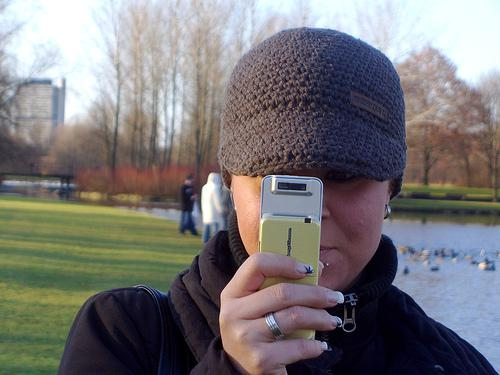Question: what color is the lady's ring?
Choices:
A. Gold.
B. Silver.
C. Yellow.
D. Grey.
Answer with the letter. Answer: B Question: where are the ducks?
Choices:
A. On the grass.
B. In the water.
C. In the sand.
D. On the carpet.
Answer with the letter. Answer: B Question: what is the color of the grass?
Choices:
A. Green.
B. Lavender.
C. Blue.
D. Turquoise.
Answer with the letter. Answer: A Question: what color is the water?
Choices:
A. Green.
B. Clear.
C. Crystal blue.
D. Blue.
Answer with the letter. Answer: D Question: where was the photo taken?
Choices:
A. At the movies.
B. At the bank.
C. At the store.
D. At a park.
Answer with the letter. Answer: D 